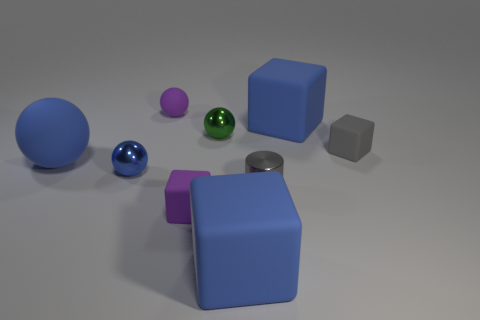Subtract all brown blocks. Subtract all cyan balls. How many blocks are left? 4 Add 1 small blue metallic balls. How many objects exist? 10 Subtract all balls. How many objects are left? 5 Add 1 large blue matte things. How many large blue matte things are left? 4 Add 2 large matte blocks. How many large matte blocks exist? 4 Subtract 0 red cylinders. How many objects are left? 9 Subtract all purple metallic cylinders. Subtract all tiny green shiny things. How many objects are left? 8 